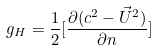Convert formula to latex. <formula><loc_0><loc_0><loc_500><loc_500>g _ { H } = \frac { 1 } { 2 } [ \frac { { \partial } ( c ^ { 2 } - { \vec { U } } ^ { 2 } ) } { { \partial } n } ]</formula> 